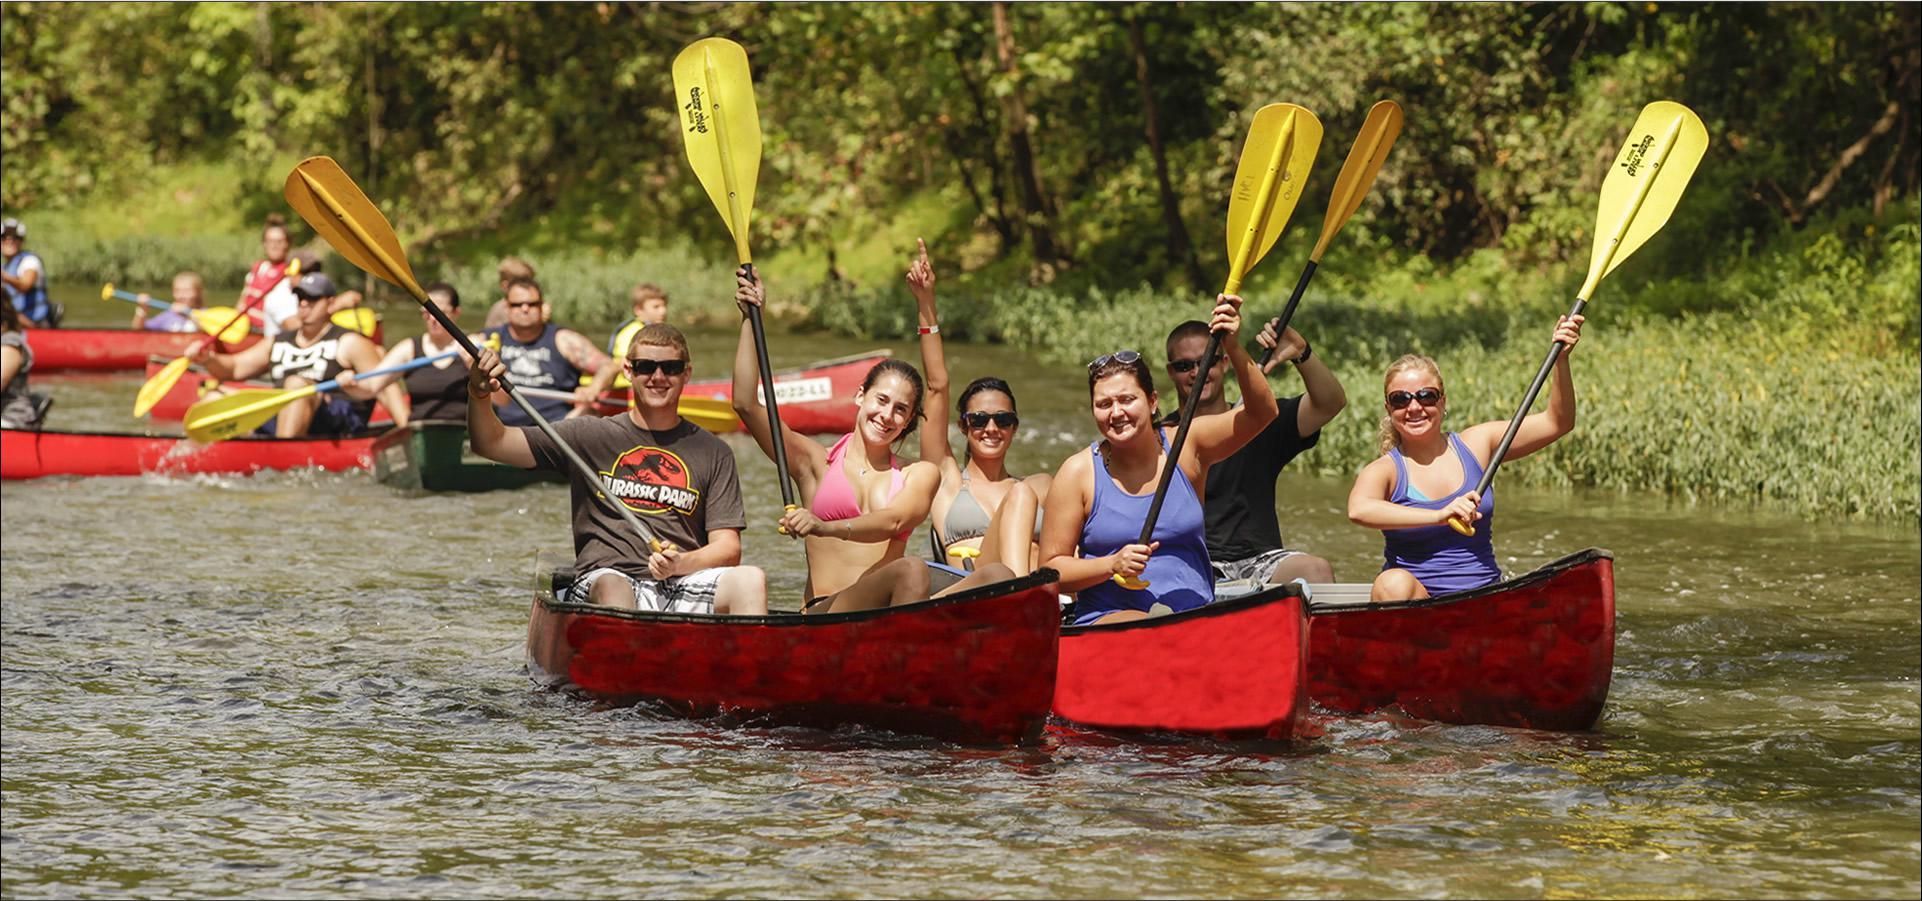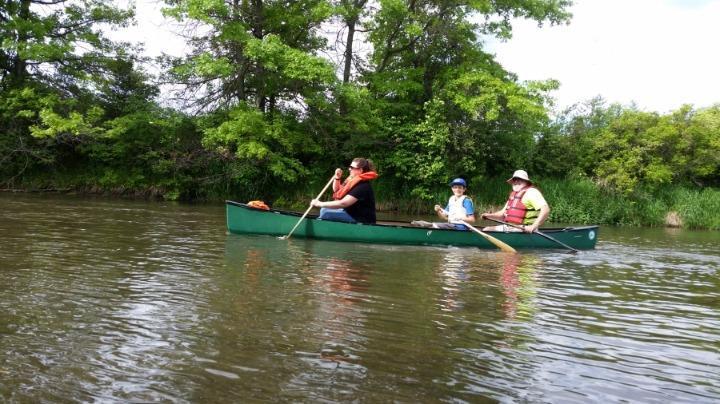The first image is the image on the left, the second image is the image on the right. For the images displayed, is the sentence "One image shows exactly one silver canoe with 3 riders." factually correct? Answer yes or no. No. The first image is the image on the left, the second image is the image on the right. Given the left and right images, does the statement "The left photo shows a single silver canoe with three passengers." hold true? Answer yes or no. No. 